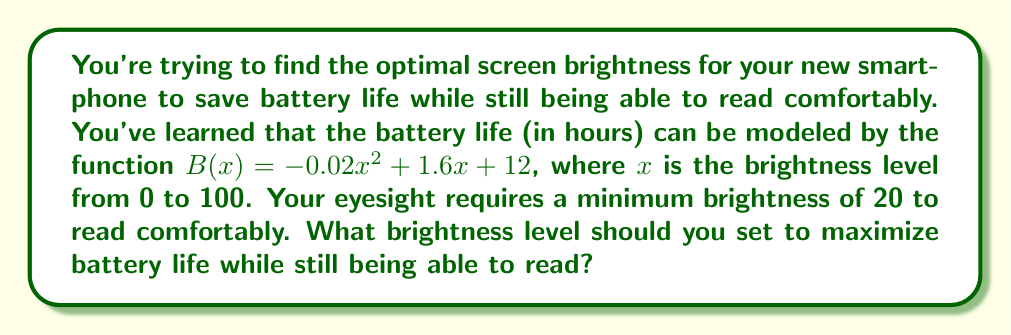Can you answer this question? To solve this problem, we need to find the maximum value of the battery life function $B(x)$ within the allowed range of $x$ values (20 to 100).

1) First, let's find the vertex of the parabola, which represents the maximum point:
   The x-coordinate of the vertex is given by $x = -\frac{b}{2a}$ where $a$ and $b$ are the coefficients of $x^2$ and $x$ respectively.

   $x = -\frac{1.6}{2(-0.02)} = 40$

2) Now we need to check if this value is within our allowed range:
   Since 40 is greater than our minimum required brightness of 20, this is a valid solution.

3) To verify, let's calculate the battery life at $x = 40$:
   
   $B(40) = -0.02(40)^2 + 1.6(40) + 12$
          $= -0.02(1600) + 64 + 12$
          $= -32 + 64 + 12$
          $= 44$ hours

4) Therefore, setting the brightness to 40 will maximize battery life while still allowing comfortable reading.
Answer: The optimal brightness level is 40, which provides a maximum battery life of 44 hours. 